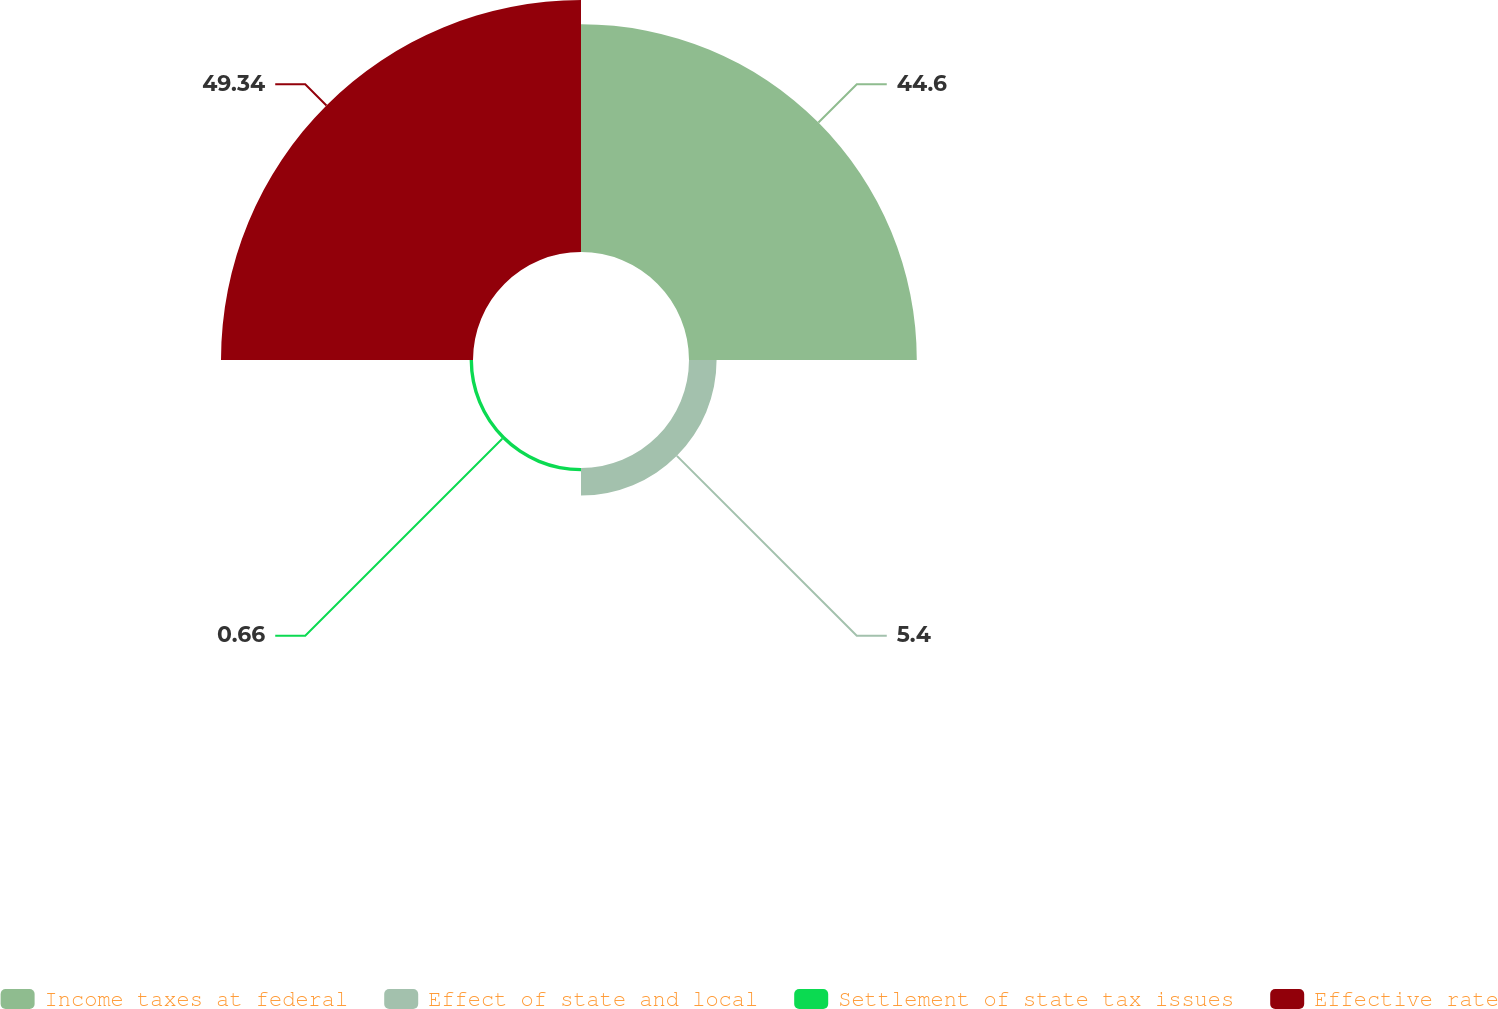<chart> <loc_0><loc_0><loc_500><loc_500><pie_chart><fcel>Income taxes at federal<fcel>Effect of state and local<fcel>Settlement of state tax issues<fcel>Effective rate<nl><fcel>44.6%<fcel>5.4%<fcel>0.66%<fcel>49.34%<nl></chart> 